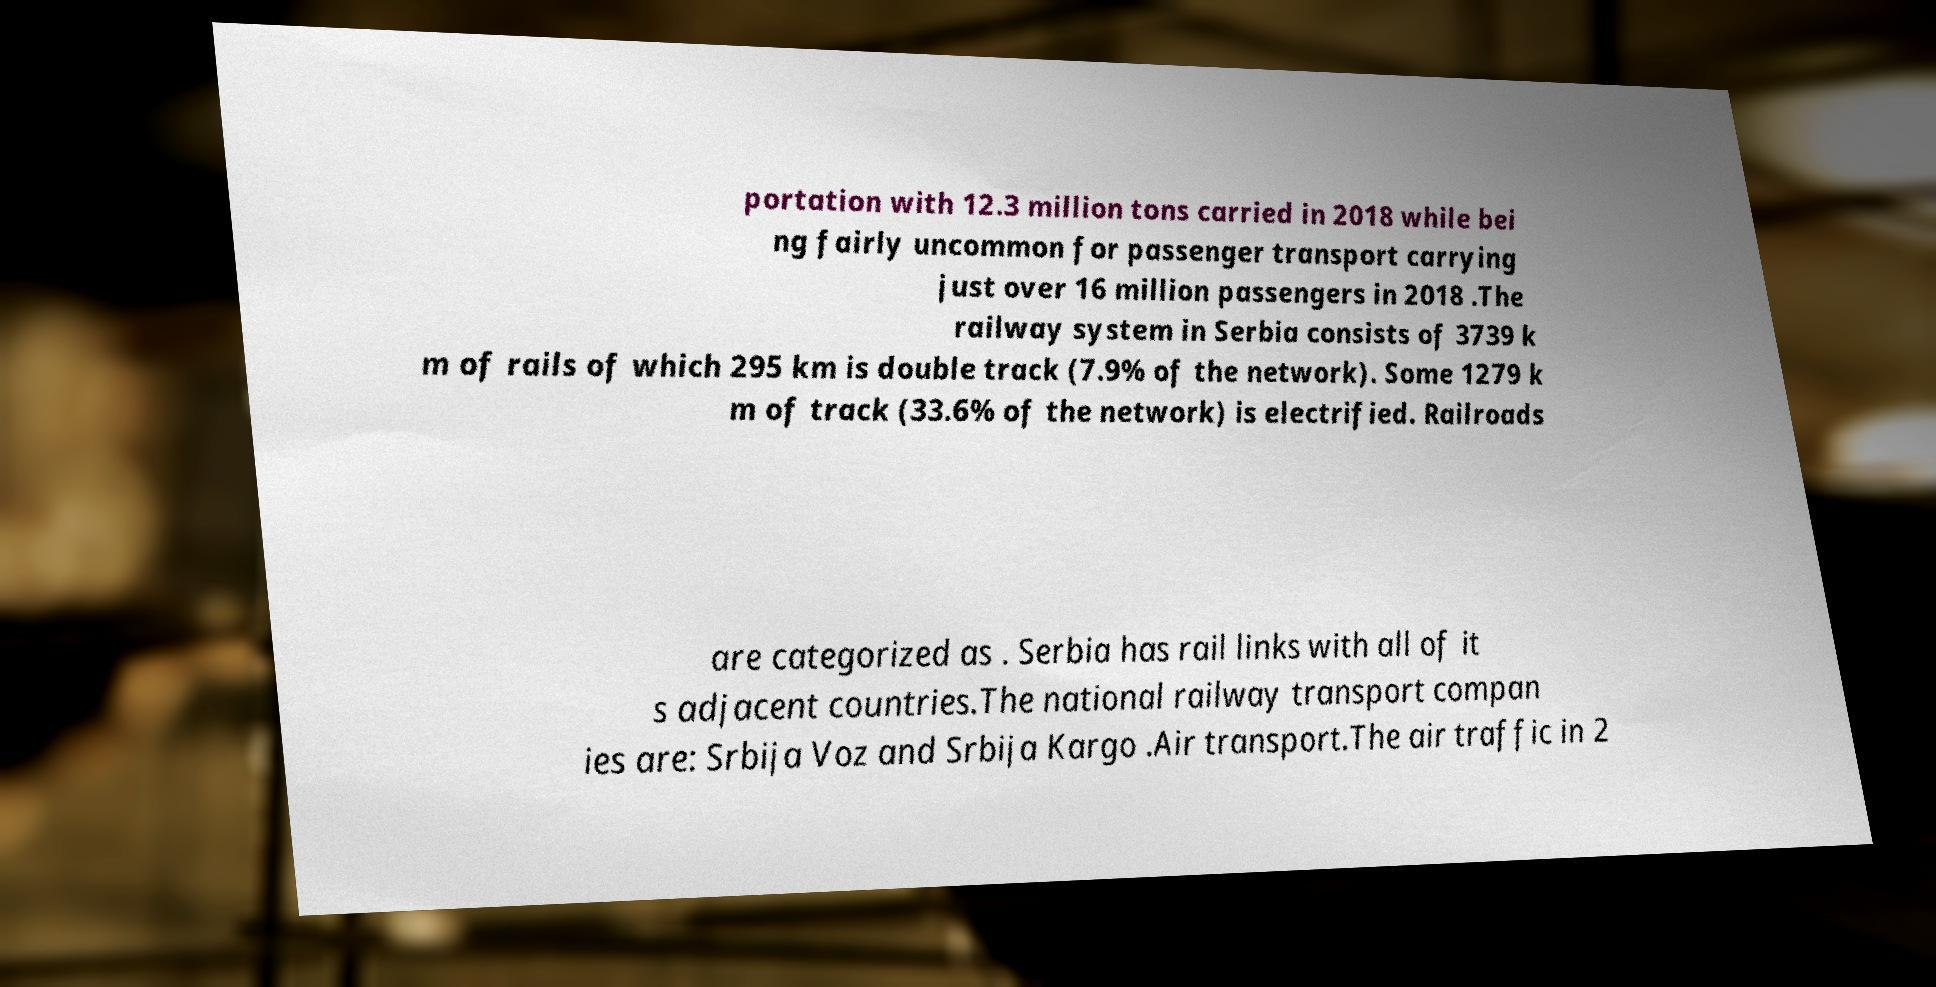Please read and relay the text visible in this image. What does it say? portation with 12.3 million tons carried in 2018 while bei ng fairly uncommon for passenger transport carrying just over 16 million passengers in 2018 .The railway system in Serbia consists of 3739 k m of rails of which 295 km is double track (7.9% of the network). Some 1279 k m of track (33.6% of the network) is electrified. Railroads are categorized as . Serbia has rail links with all of it s adjacent countries.The national railway transport compan ies are: Srbija Voz and Srbija Kargo .Air transport.The air traffic in 2 